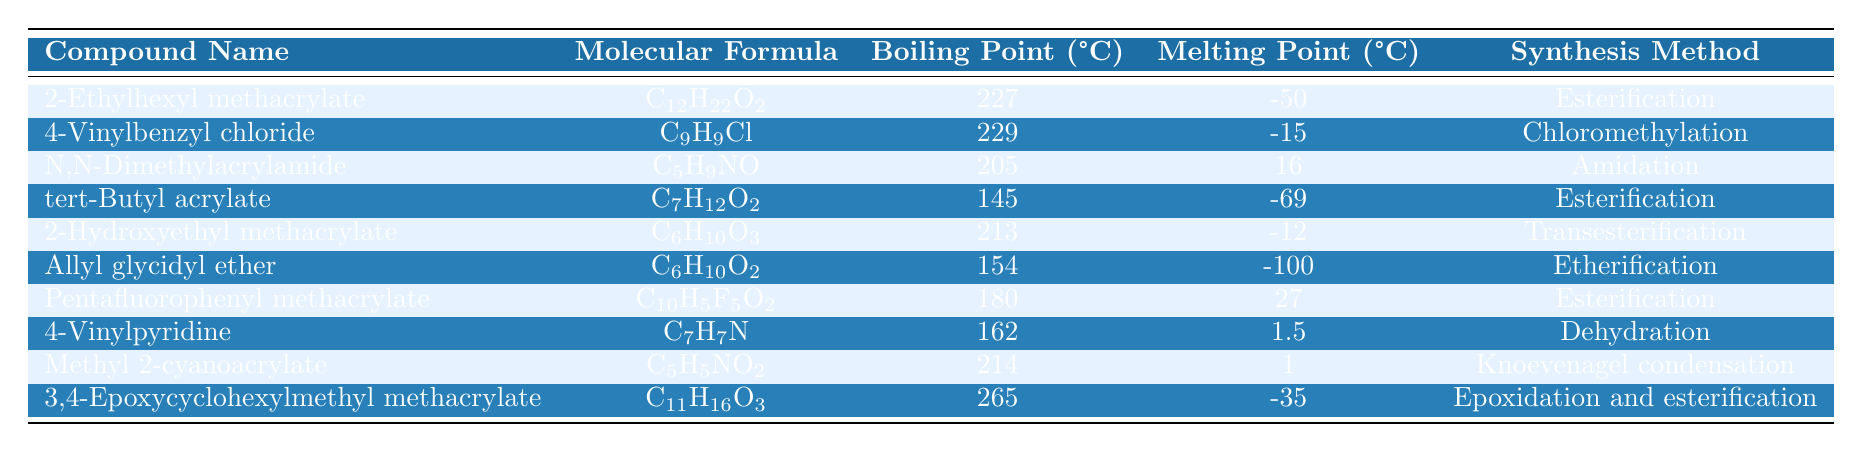What is the boiling point of 2-Ethylhexyl methacrylate? According to the table, the boiling point of 2-Ethylhexyl methacrylate is listed as 227°C.
Answer: 227°C What is the melting point of N,N-Dimethylacrylamide? Referring to the table, the melting point for N,N-Dimethylacrylamide is 16°C.
Answer: 16°C Which compound has the highest boiling point? By examining the table, 3,4-Epoxycyclohexylmethyl methacrylate has the highest boiling point, which is 265°C.
Answer: 3,4-Epoxycyclohexylmethyl methacrylate Calculate the average boiling point of the compounds listed in the table. The boiling points are: 227, 229, 205, 145, 213, 154, 180, 162, 214, and 265. Summing these gives 1,180, and dividing by 10 (the number of compounds) yields an average boiling point of 118°C.
Answer: 118°C Is the melting point of Pentafluorophenyl methacrylate greater than 20°C? The melting point for Pentafluorophenyl methacrylate is 27°C, which is greater than 20°C, making the statement true.
Answer: Yes How does the melting point of tert-Butyl acrylate compare to that of Allyl glycidyl ether? tert-Butyl acrylate has a melting point of -69°C and Allyl glycidyl ether has a melting point of -100°C. Since -69°C is higher than -100°C, tert-Butyl acrylate has a higher melting point.
Answer: tert-Butyl acrylate has a higher melting point What synthesis method is used for the compound with the lowest melting point? By analyzing the table, Allyl glycidyl ether has the lowest melting point of -100°C and its synthesis method is Etherification.
Answer: Etherification Which compounds have boiling points lower than 200°C? By checking each boiling point, the compounds with boiling points lower than 200°C are tert-Butyl acrylate (145°C), and Allyl glycidyl ether (154°C).
Answer: tert-Butyl acrylate and Allyl glycidyl ether Is there any compound that has a melting point below -70°C? According to the table, both tert-Butyl acrylate (-69°C) and Allyl glycidyl ether (-100°C) fall below -70°C, confirming the existence of such compounds.
Answer: Yes What is the difference between the boiling points of 4-Vinylbenzyl chloride and 2-Hydroxyethyl methacrylate? The boiling point of 4-Vinylbenzyl chloride is 229°C and that of 2-Hydroxyethyl methacrylate is 213°C. The difference is 229 - 213 = 16°C.
Answer: 16°C 